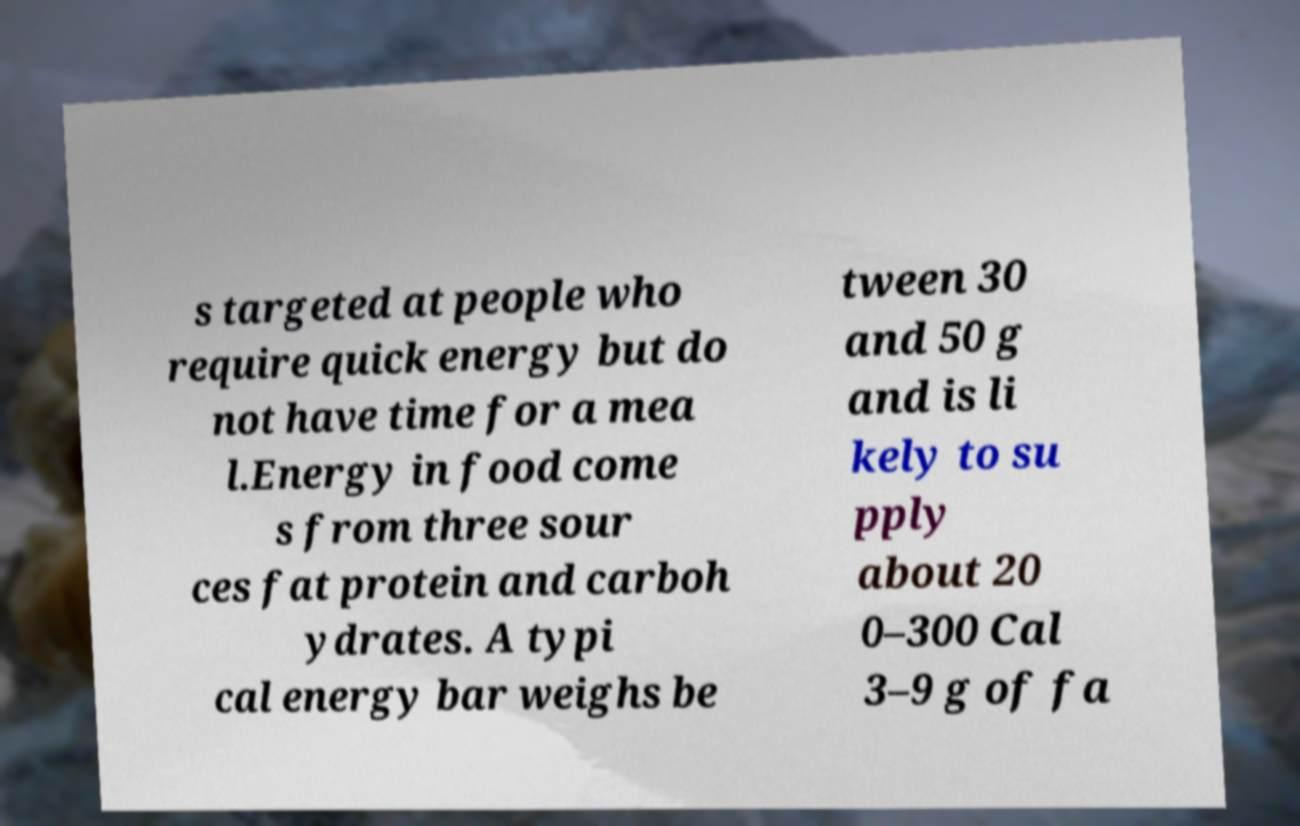There's text embedded in this image that I need extracted. Can you transcribe it verbatim? s targeted at people who require quick energy but do not have time for a mea l.Energy in food come s from three sour ces fat protein and carboh ydrates. A typi cal energy bar weighs be tween 30 and 50 g and is li kely to su pply about 20 0–300 Cal 3–9 g of fa 